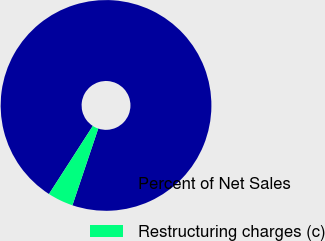<chart> <loc_0><loc_0><loc_500><loc_500><pie_chart><fcel>Percent of Net Sales<fcel>Restructuring charges (c)<nl><fcel>96.06%<fcel>3.94%<nl></chart> 